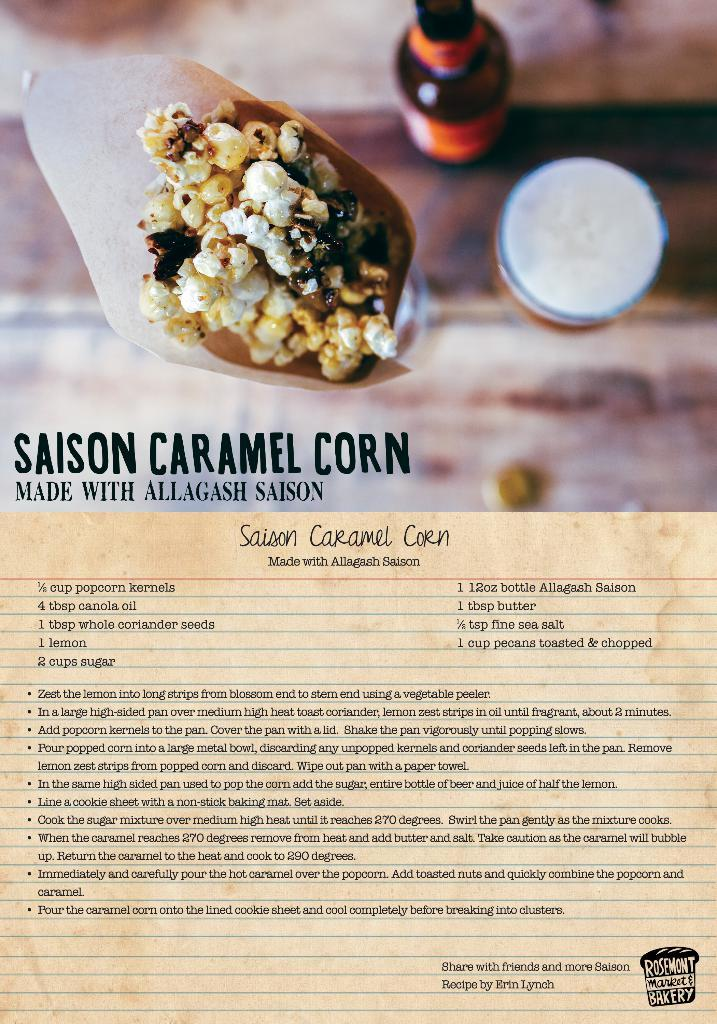<image>
Provide a brief description of the given image. A recipe page is courtesy of an establishment known as Rosemont Market & Bakery. 